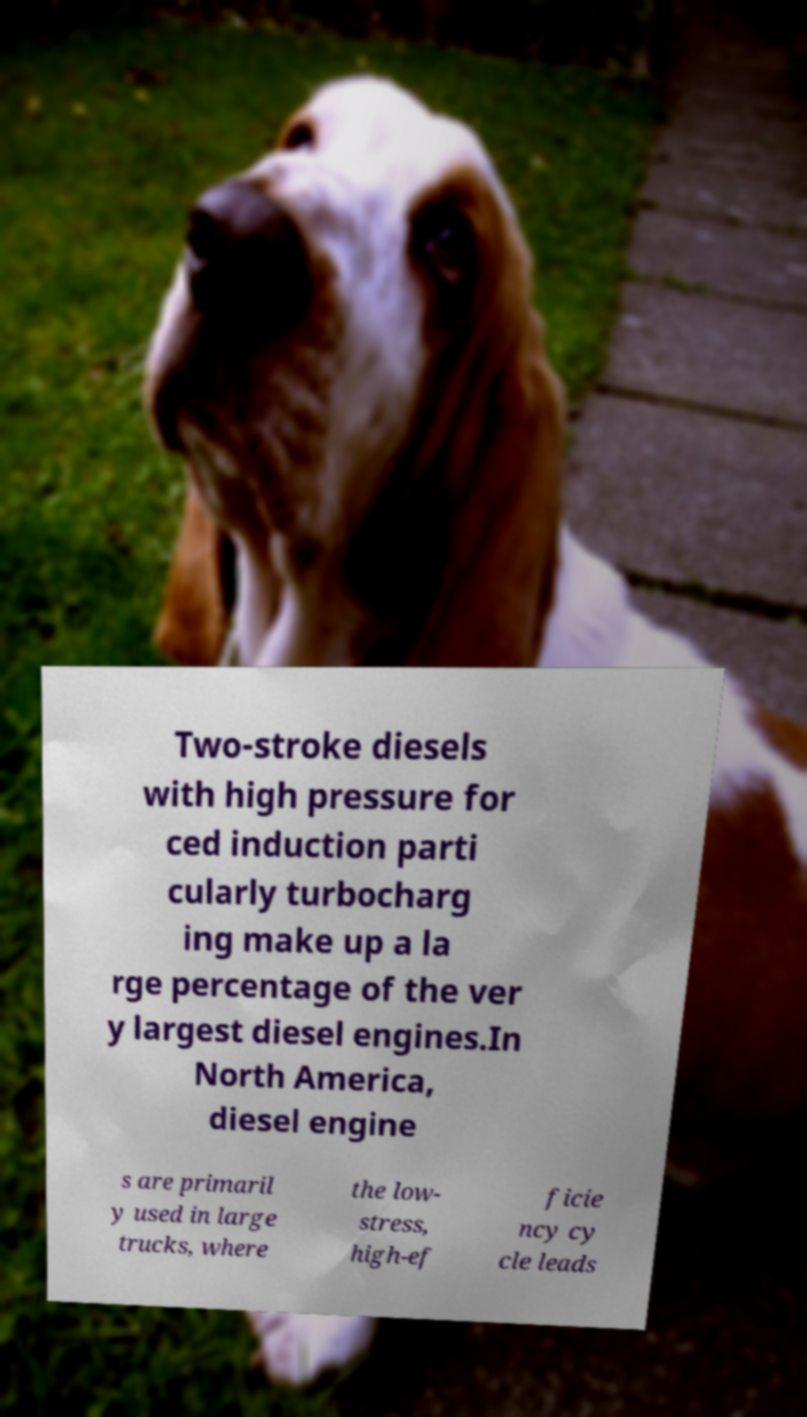For documentation purposes, I need the text within this image transcribed. Could you provide that? Two-stroke diesels with high pressure for ced induction parti cularly turbocharg ing make up a la rge percentage of the ver y largest diesel engines.In North America, diesel engine s are primaril y used in large trucks, where the low- stress, high-ef ficie ncy cy cle leads 